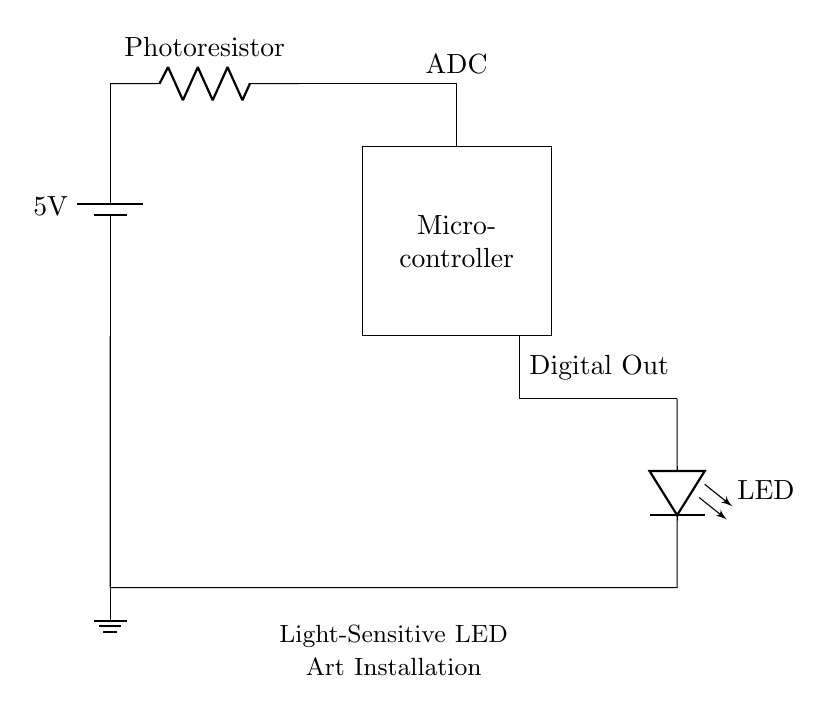What is the main power supply voltage for the circuit? The power supply is a battery labeled with a voltage of 5V. It is indicated in the circuit drawing that connects to the photoresistor and other components.
Answer: 5 volts What type of sensor is used in this installation? The circuit includes a photoresistor, which is a light-sensitive component that changes resistance based on the light intensity falling on it. It is used to control the LED.
Answer: Photoresistor What does the microcontroller do in this circuit? The microcontroller processes the input from the photoresistor, which is connected via the ADC (Analog to Digital Converter) input, and can control the digital output based on this input.
Answer: Control LED How many outputs are shown for the microcontroller? The microcontroller has one digital output indicated in the diagram, which is used to connect to the LED for light activation.
Answer: One What is the intended function of the LED in this circuit? The LED is activated or controlled based on the readings from the photoresistor, making it turn on or off depending on the surrounding light levels.
Answer: Light-sensitive What is the connection type between the photoresistor and the microcontroller? The connection between the photoresistor and the microcontroller is made through an ADC input, allowing the microcontroller to read the analog value from the photoresistor.
Answer: ADC input What is the total current flow direction in this circuit? The total current flows from the battery through the photoresistor, then into the microcontroller, and finally to the LED before returning to ground.
Answer: Clockwise 